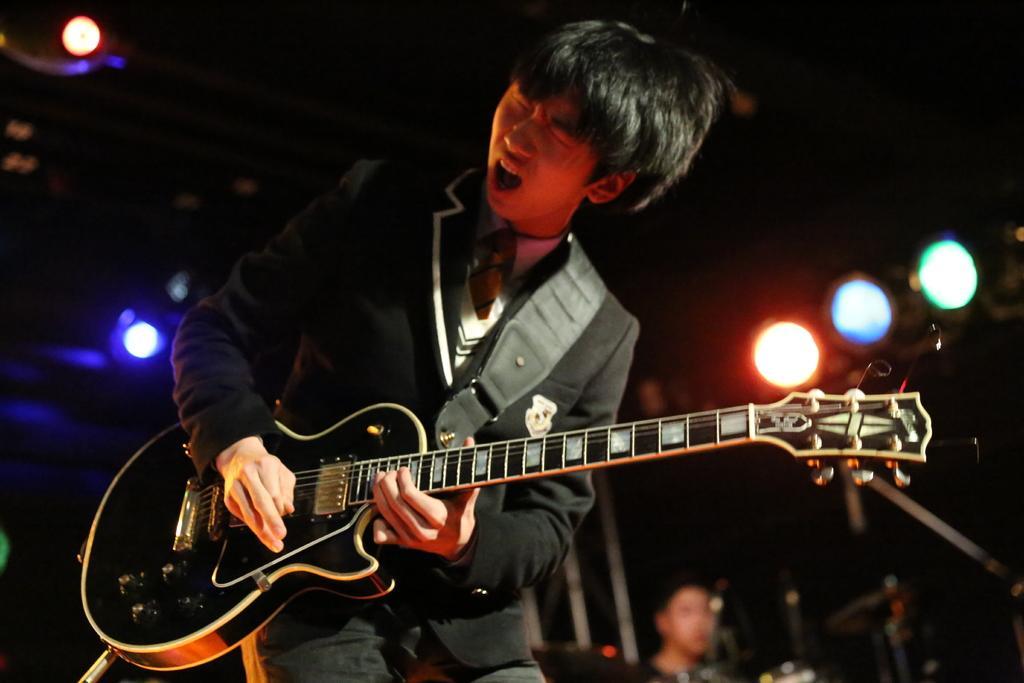Describe this image in one or two sentences. In this image I can see a person wearing the blazer and playing the guitar. In the background there is another person and lights. 